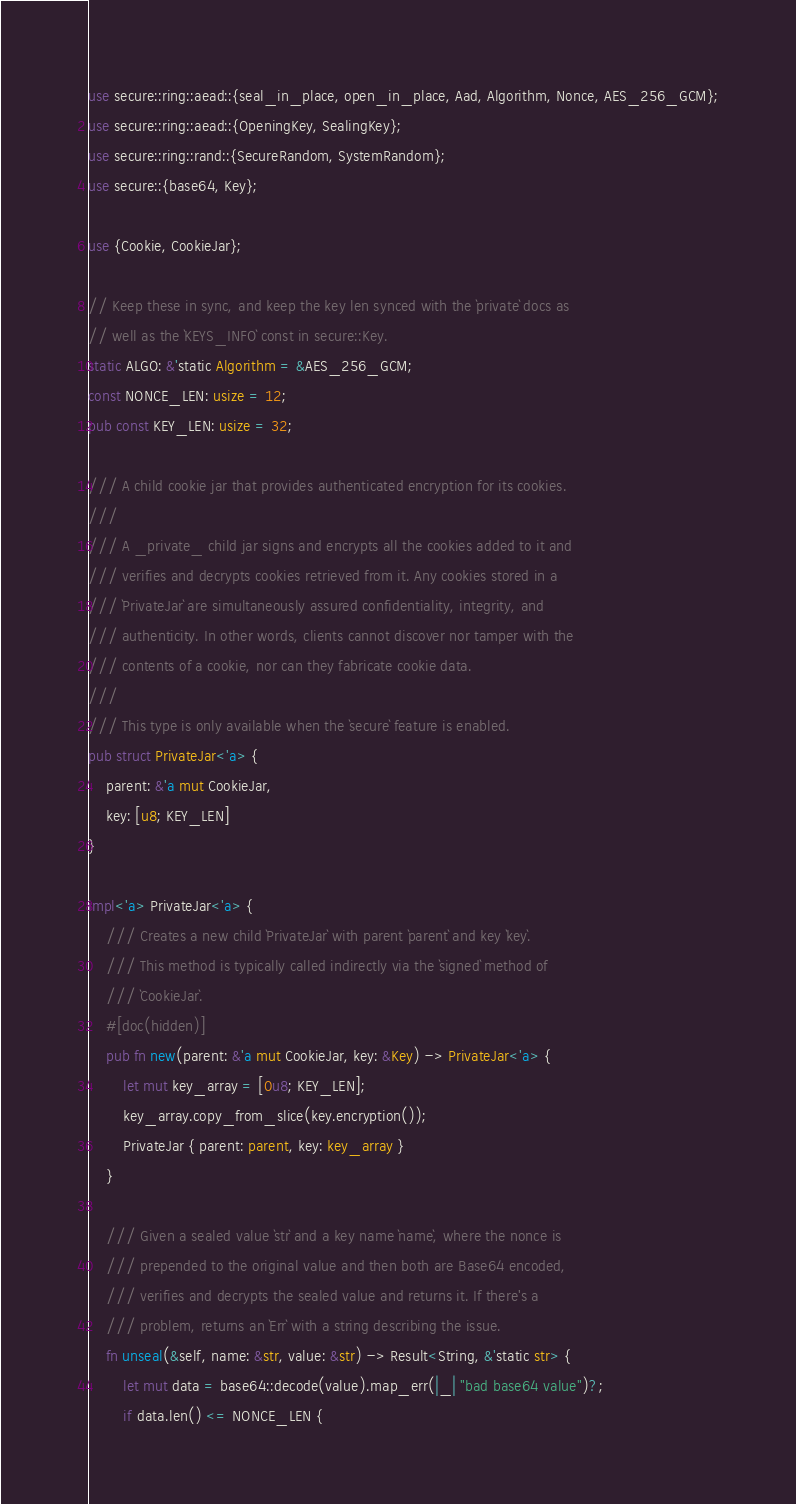Convert code to text. <code><loc_0><loc_0><loc_500><loc_500><_Rust_>use secure::ring::aead::{seal_in_place, open_in_place, Aad, Algorithm, Nonce, AES_256_GCM};
use secure::ring::aead::{OpeningKey, SealingKey};
use secure::ring::rand::{SecureRandom, SystemRandom};
use secure::{base64, Key};

use {Cookie, CookieJar};

// Keep these in sync, and keep the key len synced with the `private` docs as
// well as the `KEYS_INFO` const in secure::Key.
static ALGO: &'static Algorithm = &AES_256_GCM;
const NONCE_LEN: usize = 12;
pub const KEY_LEN: usize = 32;

/// A child cookie jar that provides authenticated encryption for its cookies.
///
/// A _private_ child jar signs and encrypts all the cookies added to it and
/// verifies and decrypts cookies retrieved from it. Any cookies stored in a
/// `PrivateJar` are simultaneously assured confidentiality, integrity, and
/// authenticity. In other words, clients cannot discover nor tamper with the
/// contents of a cookie, nor can they fabricate cookie data.
///
/// This type is only available when the `secure` feature is enabled.
pub struct PrivateJar<'a> {
    parent: &'a mut CookieJar,
    key: [u8; KEY_LEN]
}

impl<'a> PrivateJar<'a> {
    /// Creates a new child `PrivateJar` with parent `parent` and key `key`.
    /// This method is typically called indirectly via the `signed` method of
    /// `CookieJar`.
    #[doc(hidden)]
    pub fn new(parent: &'a mut CookieJar, key: &Key) -> PrivateJar<'a> {
        let mut key_array = [0u8; KEY_LEN];
        key_array.copy_from_slice(key.encryption());
        PrivateJar { parent: parent, key: key_array }
    }

    /// Given a sealed value `str` and a key name `name`, where the nonce is
    /// prepended to the original value and then both are Base64 encoded,
    /// verifies and decrypts the sealed value and returns it. If there's a
    /// problem, returns an `Err` with a string describing the issue.
    fn unseal(&self, name: &str, value: &str) -> Result<String, &'static str> {
        let mut data = base64::decode(value).map_err(|_| "bad base64 value")?;
        if data.len() <= NONCE_LEN {</code> 